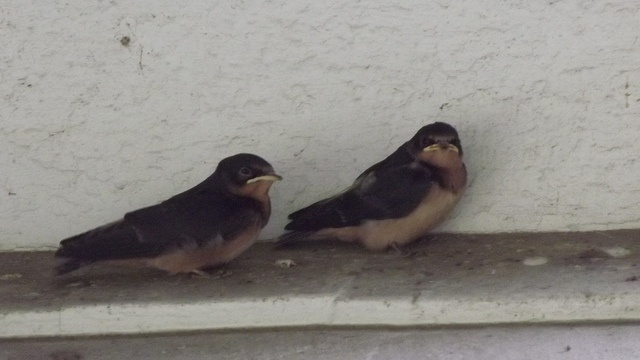Describe the objects in this image and their specific colors. I can see bird in darkgray, black, and gray tones and bird in darkgray, black, and gray tones in this image. 